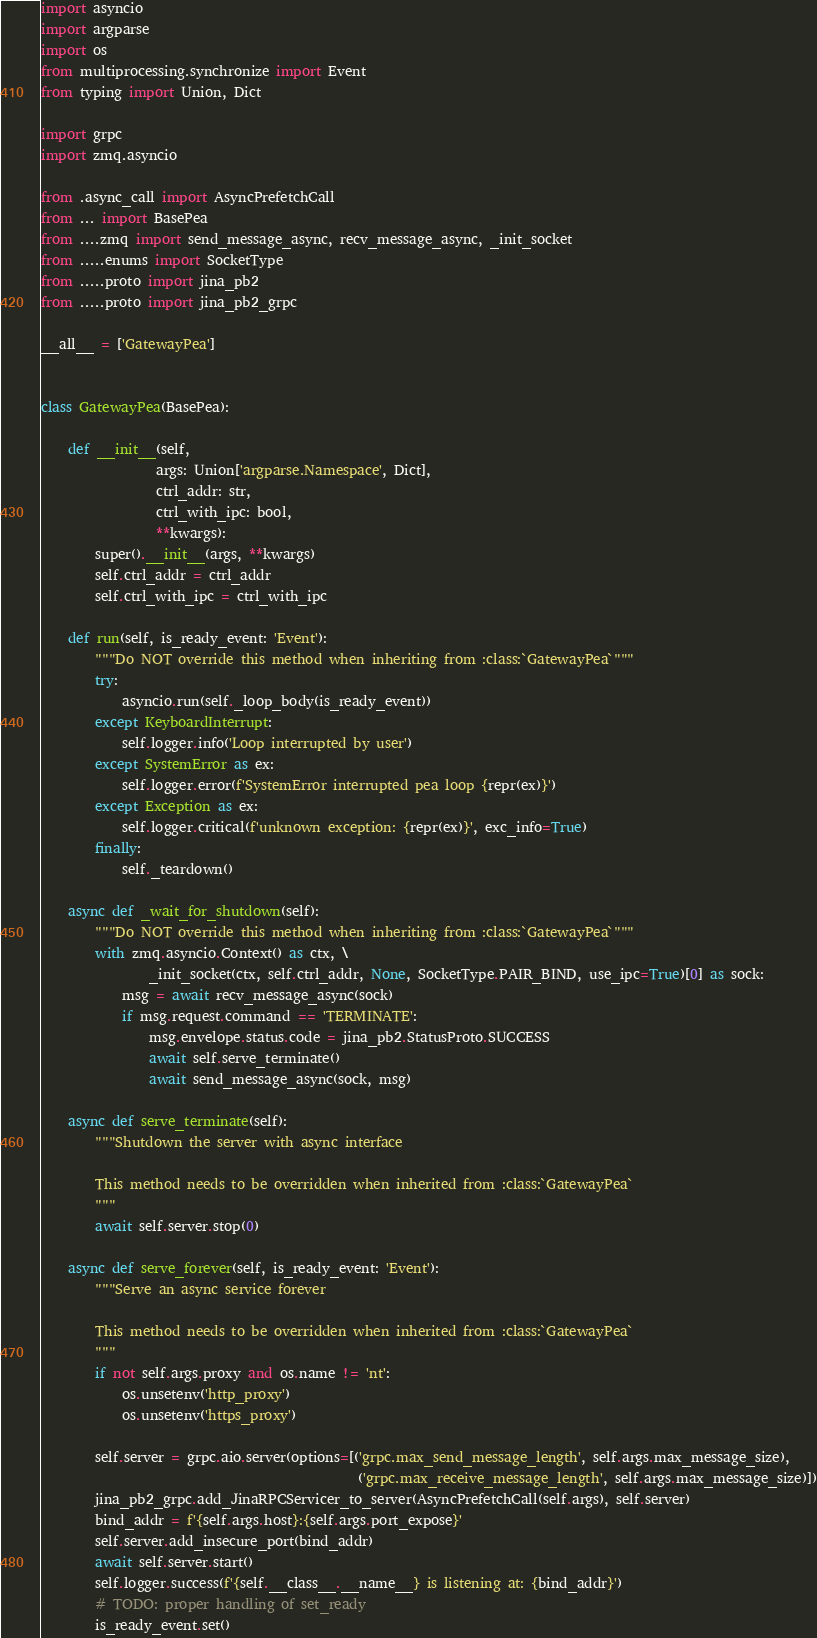Convert code to text. <code><loc_0><loc_0><loc_500><loc_500><_Python_>import asyncio
import argparse
import os
from multiprocessing.synchronize import Event
from typing import Union, Dict

import grpc
import zmq.asyncio

from .async_call import AsyncPrefetchCall
from ... import BasePea
from ....zmq import send_message_async, recv_message_async, _init_socket
from .....enums import SocketType
from .....proto import jina_pb2
from .....proto import jina_pb2_grpc

__all__ = ['GatewayPea']


class GatewayPea(BasePea):

    def __init__(self,
                 args: Union['argparse.Namespace', Dict],
                 ctrl_addr: str,
                 ctrl_with_ipc: bool,
                 **kwargs):
        super().__init__(args, **kwargs)
        self.ctrl_addr = ctrl_addr
        self.ctrl_with_ipc = ctrl_with_ipc

    def run(self, is_ready_event: 'Event'):
        """Do NOT override this method when inheriting from :class:`GatewayPea`"""
        try:
            asyncio.run(self._loop_body(is_ready_event))
        except KeyboardInterrupt:
            self.logger.info('Loop interrupted by user')
        except SystemError as ex:
            self.logger.error(f'SystemError interrupted pea loop {repr(ex)}')
        except Exception as ex:
            self.logger.critical(f'unknown exception: {repr(ex)}', exc_info=True)
        finally:
            self._teardown()

    async def _wait_for_shutdown(self):
        """Do NOT override this method when inheriting from :class:`GatewayPea`"""
        with zmq.asyncio.Context() as ctx, \
                _init_socket(ctx, self.ctrl_addr, None, SocketType.PAIR_BIND, use_ipc=True)[0] as sock:
            msg = await recv_message_async(sock)
            if msg.request.command == 'TERMINATE':
                msg.envelope.status.code = jina_pb2.StatusProto.SUCCESS
                await self.serve_terminate()
                await send_message_async(sock, msg)

    async def serve_terminate(self):
        """Shutdown the server with async interface

        This method needs to be overridden when inherited from :class:`GatewayPea`
        """
        await self.server.stop(0)

    async def serve_forever(self, is_ready_event: 'Event'):
        """Serve an async service forever

        This method needs to be overridden when inherited from :class:`GatewayPea`
        """
        if not self.args.proxy and os.name != 'nt':
            os.unsetenv('http_proxy')
            os.unsetenv('https_proxy')

        self.server = grpc.aio.server(options=[('grpc.max_send_message_length', self.args.max_message_size),
                                               ('grpc.max_receive_message_length', self.args.max_message_size)])
        jina_pb2_grpc.add_JinaRPCServicer_to_server(AsyncPrefetchCall(self.args), self.server)
        bind_addr = f'{self.args.host}:{self.args.port_expose}'
        self.server.add_insecure_port(bind_addr)
        await self.server.start()
        self.logger.success(f'{self.__class__.__name__} is listening at: {bind_addr}')
        # TODO: proper handling of set_ready
        is_ready_event.set()</code> 